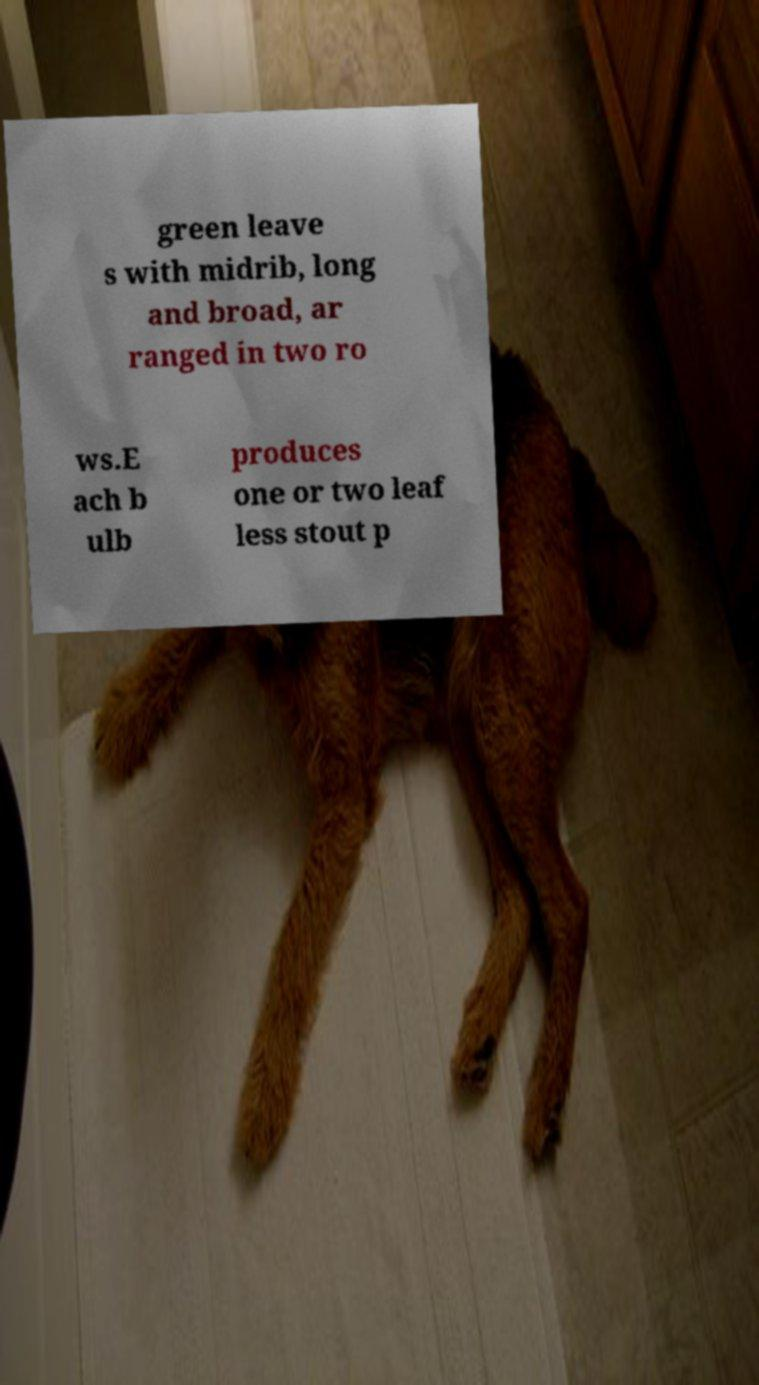Can you accurately transcribe the text from the provided image for me? green leave s with midrib, long and broad, ar ranged in two ro ws.E ach b ulb produces one or two leaf less stout p 